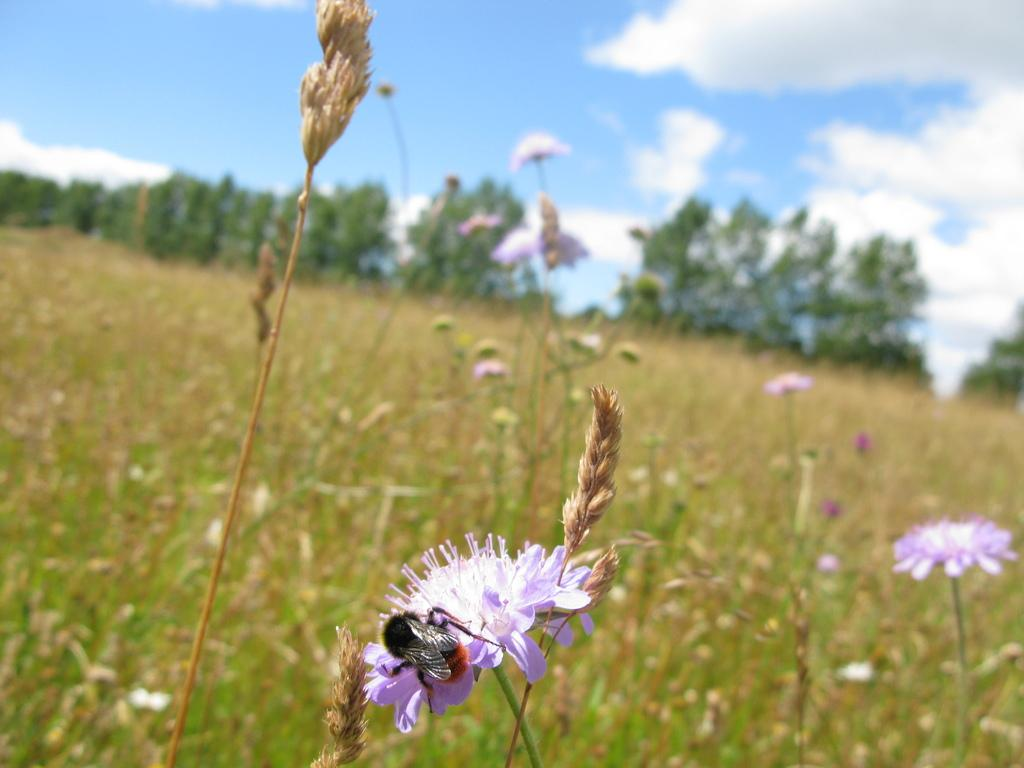What type of vegetation is at the bottom of the image? There are flower plants at the bottom of the image. What can be seen in the background of the image? There are trees in the background of the image. What is visible at the top of the image? The sky is visible at the top of the image. How would you describe the sky in the image? The sky appears to be cloudy. What type of food is being served in the hat in the image? There is no hat or food present in the image. What time of day is depicted in the image? The provided facts do not give any information about the time of day, so it cannot be determined from the image. 